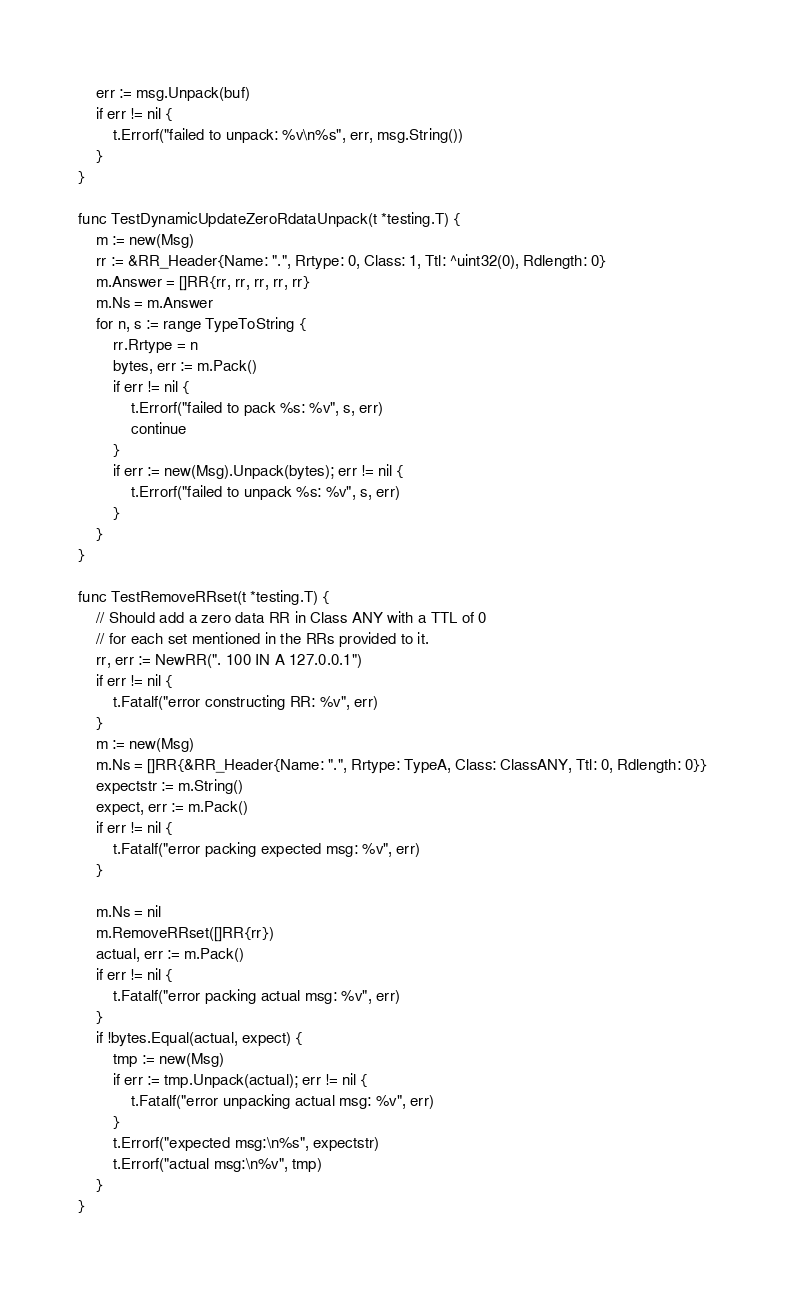<code> <loc_0><loc_0><loc_500><loc_500><_Go_>	err := msg.Unpack(buf)
	if err != nil {
		t.Errorf("failed to unpack: %v\n%s", err, msg.String())
	}
}

func TestDynamicUpdateZeroRdataUnpack(t *testing.T) {
	m := new(Msg)
	rr := &RR_Header{Name: ".", Rrtype: 0, Class: 1, Ttl: ^uint32(0), Rdlength: 0}
	m.Answer = []RR{rr, rr, rr, rr, rr}
	m.Ns = m.Answer
	for n, s := range TypeToString {
		rr.Rrtype = n
		bytes, err := m.Pack()
		if err != nil {
			t.Errorf("failed to pack %s: %v", s, err)
			continue
		}
		if err := new(Msg).Unpack(bytes); err != nil {
			t.Errorf("failed to unpack %s: %v", s, err)
		}
	}
}

func TestRemoveRRset(t *testing.T) {
	// Should add a zero data RR in Class ANY with a TTL of 0
	// for each set mentioned in the RRs provided to it.
	rr, err := NewRR(". 100 IN A 127.0.0.1")
	if err != nil {
		t.Fatalf("error constructing RR: %v", err)
	}
	m := new(Msg)
	m.Ns = []RR{&RR_Header{Name: ".", Rrtype: TypeA, Class: ClassANY, Ttl: 0, Rdlength: 0}}
	expectstr := m.String()
	expect, err := m.Pack()
	if err != nil {
		t.Fatalf("error packing expected msg: %v", err)
	}

	m.Ns = nil
	m.RemoveRRset([]RR{rr})
	actual, err := m.Pack()
	if err != nil {
		t.Fatalf("error packing actual msg: %v", err)
	}
	if !bytes.Equal(actual, expect) {
		tmp := new(Msg)
		if err := tmp.Unpack(actual); err != nil {
			t.Fatalf("error unpacking actual msg: %v", err)
		}
		t.Errorf("expected msg:\n%s", expectstr)
		t.Errorf("actual msg:\n%v", tmp)
	}
}
</code> 